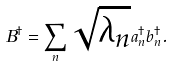Convert formula to latex. <formula><loc_0><loc_0><loc_500><loc_500>B ^ { \dagger } = \sum _ { n } \sqrt { \lambda _ { n } } a _ { n } ^ { \dagger } b _ { n } ^ { \dagger } .</formula> 